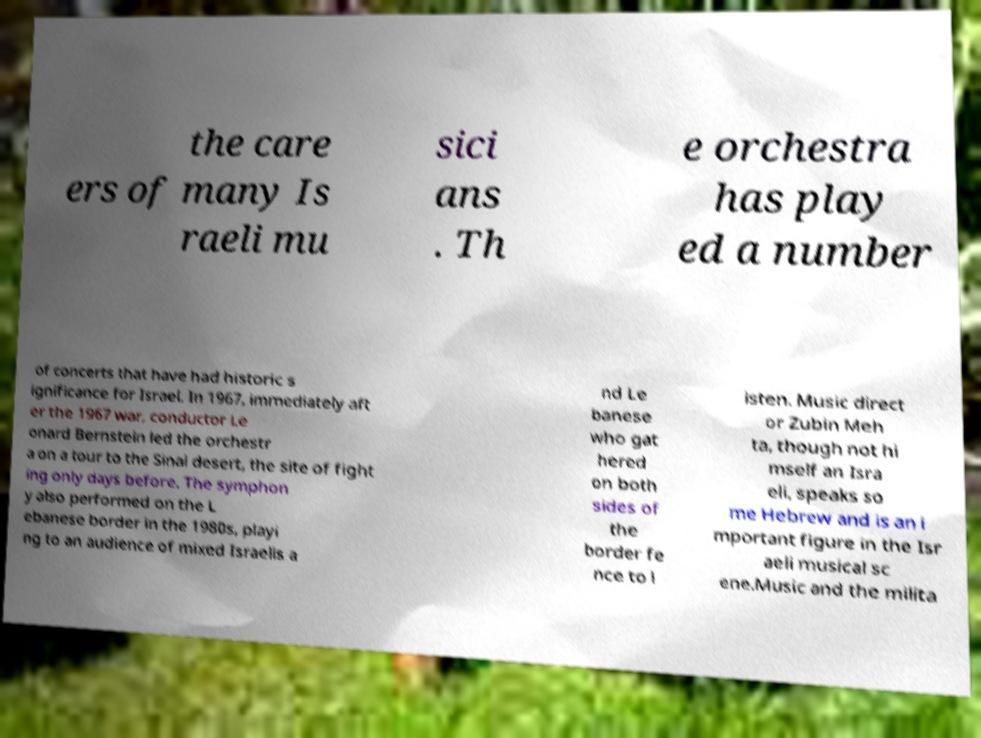Can you read and provide the text displayed in the image?This photo seems to have some interesting text. Can you extract and type it out for me? the care ers of many Is raeli mu sici ans . Th e orchestra has play ed a number of concerts that have had historic s ignificance for Israel. In 1967, immediately aft er the 1967 war, conductor Le onard Bernstein led the orchestr a on a tour to the Sinai desert, the site of fight ing only days before. The symphon y also performed on the L ebanese border in the 1980s, playi ng to an audience of mixed Israelis a nd Le banese who gat hered on both sides of the border fe nce to l isten. Music direct or Zubin Meh ta, though not hi mself an Isra eli, speaks so me Hebrew and is an i mportant figure in the Isr aeli musical sc ene.Music and the milita 